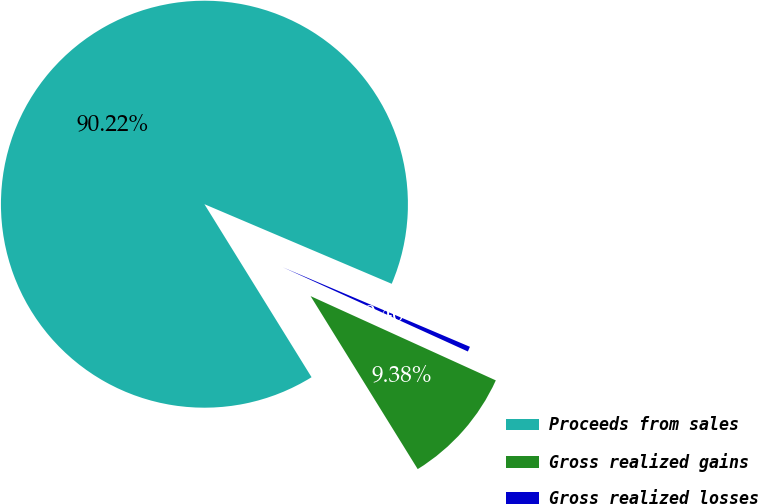Convert chart. <chart><loc_0><loc_0><loc_500><loc_500><pie_chart><fcel>Proceeds from sales<fcel>Gross realized gains<fcel>Gross realized losses<nl><fcel>90.22%<fcel>9.38%<fcel>0.4%<nl></chart> 